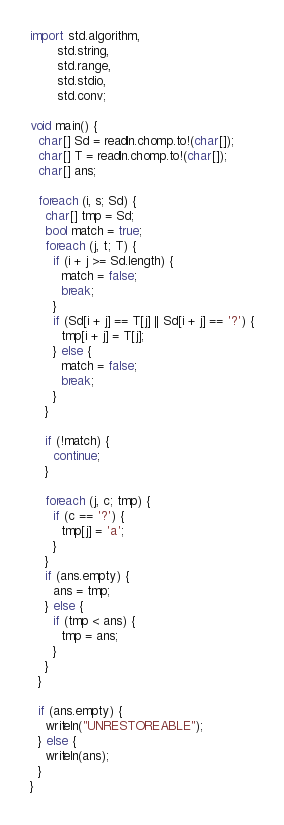<code> <loc_0><loc_0><loc_500><loc_500><_D_>import std.algorithm,
       std.string,
       std.range,
       std.stdio,
       std.conv;

void main() {
  char[] Sd = readln.chomp.to!(char[]);
  char[] T = readln.chomp.to!(char[]);
  char[] ans;

  foreach (i, s; Sd) {
    char[] tmp = Sd;
    bool match = true;
    foreach (j, t; T) {
      if (i + j >= Sd.length) {
        match = false;
        break;
      }
      if (Sd[i + j] == T[j] || Sd[i + j] == '?') {
        tmp[i + j] = T[j];
      } else {
        match = false;
        break;
      }
    }

    if (!match) {
      continue;
    }

    foreach (j, c; tmp) {
      if (c == '?') {
        tmp[j] = 'a';
      }
    }
    if (ans.empty) {
      ans = tmp;
    } else {
      if (tmp < ans) {
        tmp = ans;
      }
    }
  }

  if (ans.empty) {
    writeln("UNRESTOREABLE");
  } else {
    writeln(ans);
  }
}
</code> 